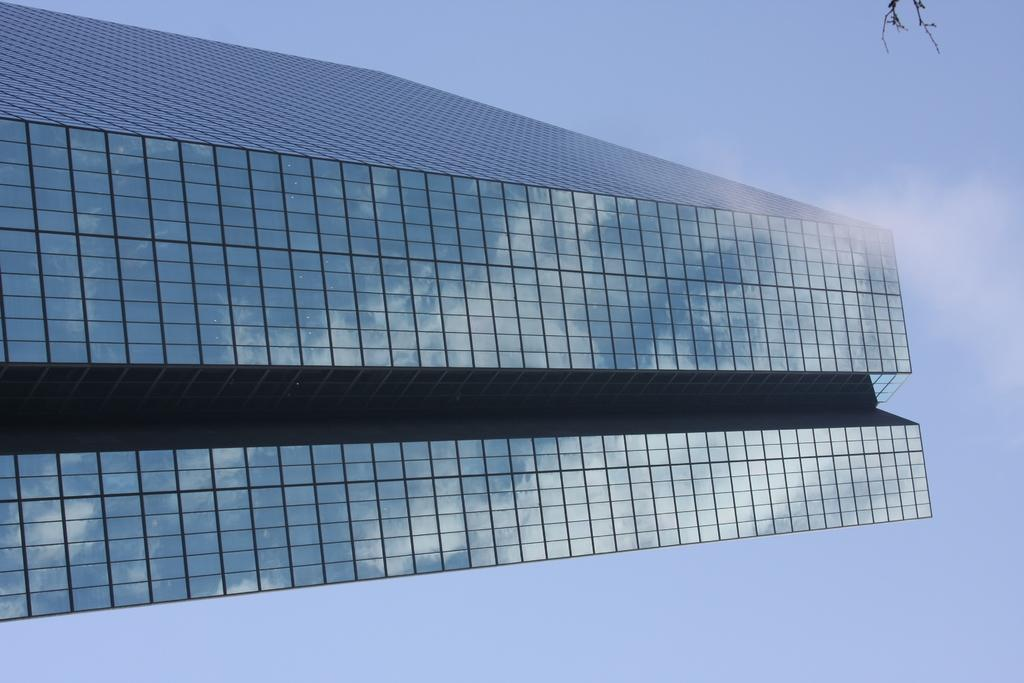What is the main structure visible in the image? There is a building in the front of the image. What can be seen in the distance behind the building? The sky is visible in the background of the image. What color are the objects located on the top right side of the image? The objects on the top right side of the image are black-colored. What is the title of the horse in the image? There is no horse present in the image, so there is no title to discuss. 